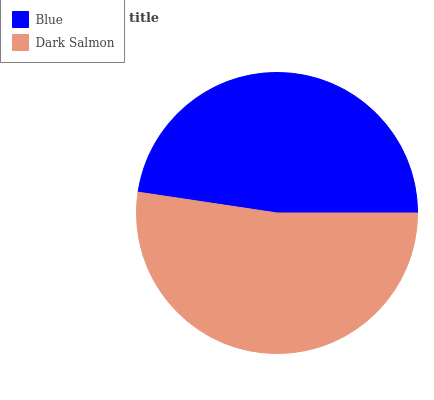Is Blue the minimum?
Answer yes or no. Yes. Is Dark Salmon the maximum?
Answer yes or no. Yes. Is Dark Salmon the minimum?
Answer yes or no. No. Is Dark Salmon greater than Blue?
Answer yes or no. Yes. Is Blue less than Dark Salmon?
Answer yes or no. Yes. Is Blue greater than Dark Salmon?
Answer yes or no. No. Is Dark Salmon less than Blue?
Answer yes or no. No. Is Dark Salmon the high median?
Answer yes or no. Yes. Is Blue the low median?
Answer yes or no. Yes. Is Blue the high median?
Answer yes or no. No. Is Dark Salmon the low median?
Answer yes or no. No. 